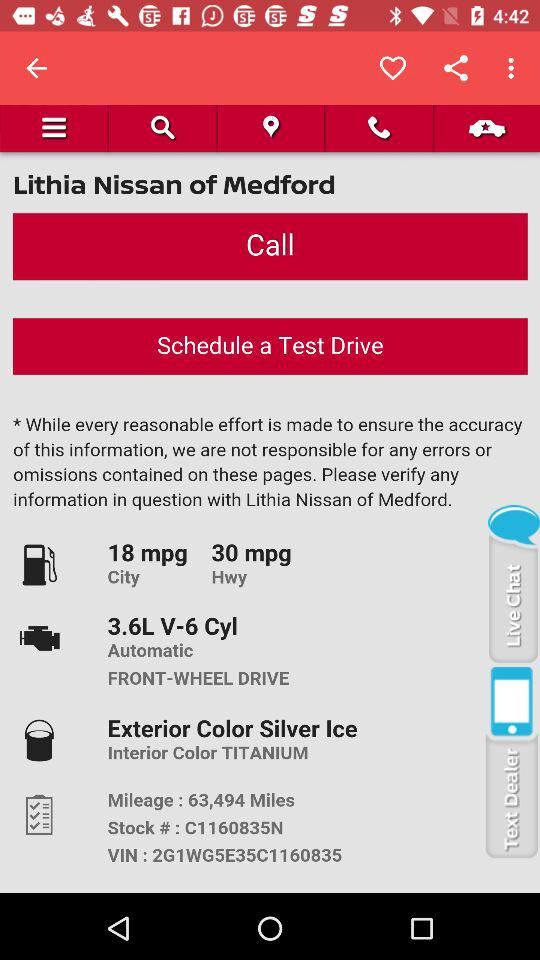What is the VIN of the car?
Answer the question using a single word or phrase. 2G1WG5E35C1160835 